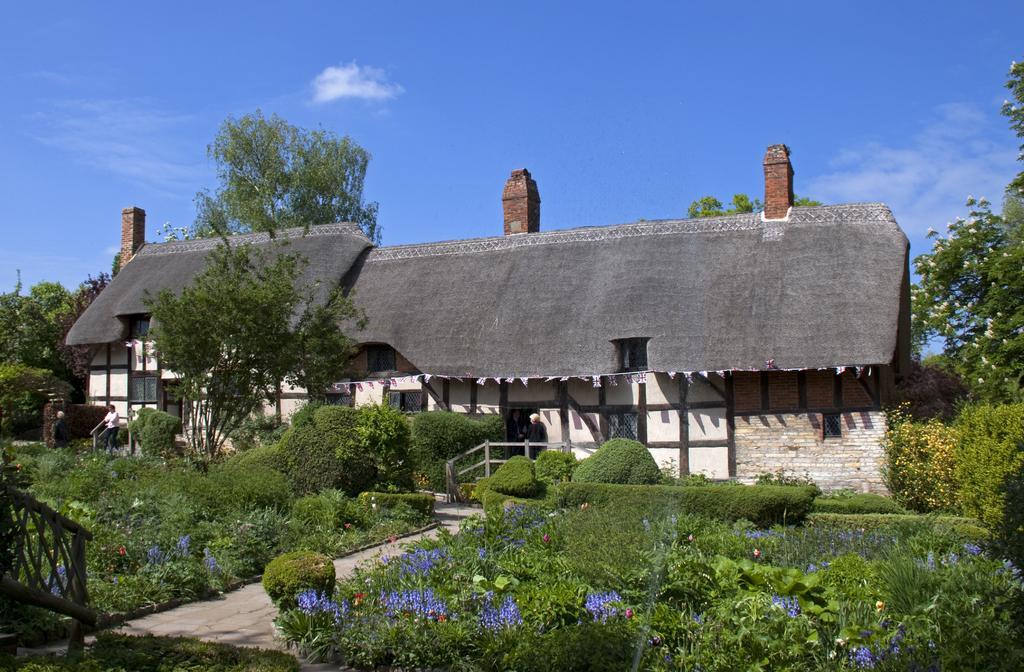Could you give a brief overview of what you see in this image? This image is taken outdoors. At the top of the image there is the sky with clouds. At the bottom of the image there is a ground with grass on it. In the middle of the image there is a house. There are many trees and plants with leaves, flowers, stems and branches. There is a person standing on the floor. 